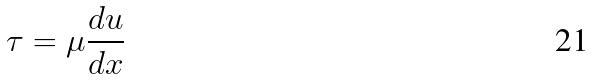Convert formula to latex. <formula><loc_0><loc_0><loc_500><loc_500>\tau = \mu \frac { d u } { d x }</formula> 